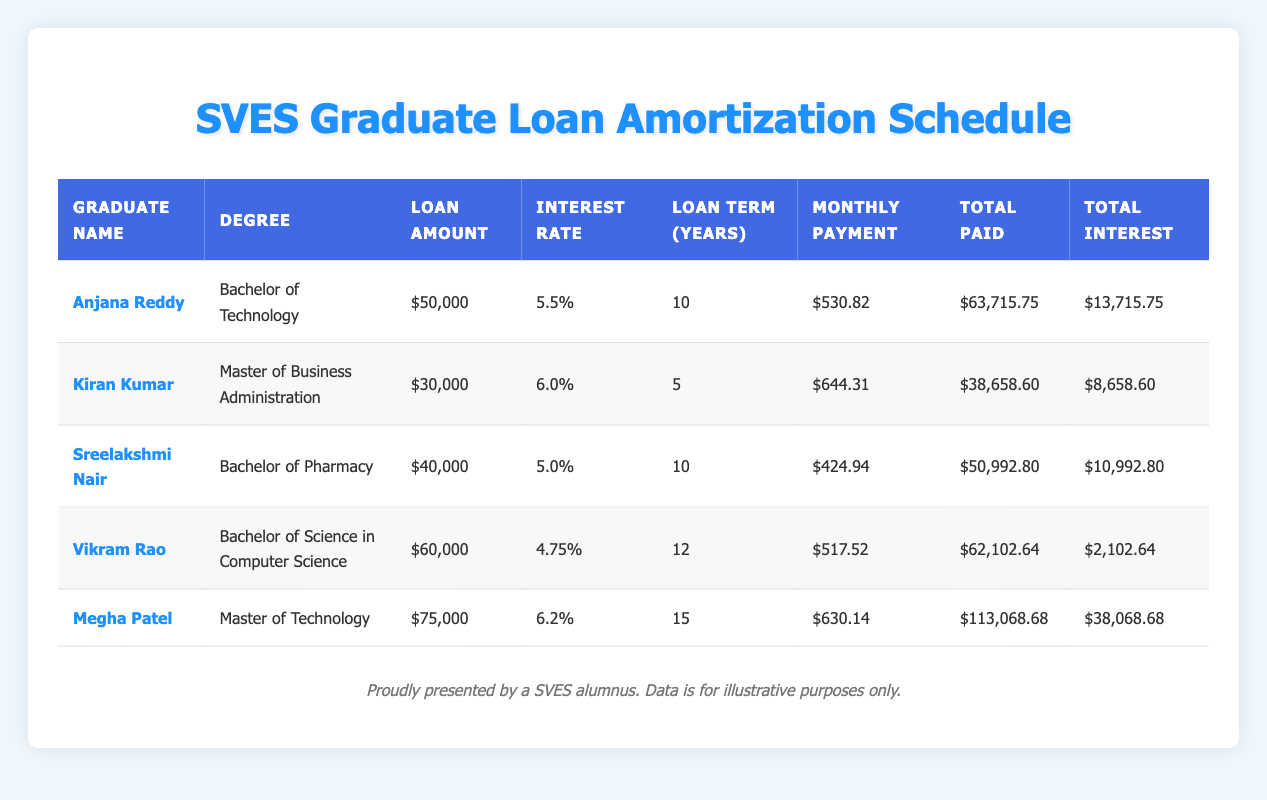What is the loan amount taken by Anjana Reddy? In the table, Anjana Reddy's information displays her loan amount clearly. Under the "Loan Amount" column, it shows $50,000 as her loan.
Answer: $50,000 What is the monthly payment for Kiran Kumar? Kiran Kumar's monthly payment can be found in the "Monthly Payment" column next to his name. It lists $644.31, which is the amount he will pay monthly for his loan.
Answer: $644.31 Which graduate has the highest total interest paid? To find the graduate with the highest total interest paid, we can look at the "Total Interest" column and compare the values. Megha Patel has $38,068.68, which is higher than all other graduates' totals.
Answer: Megha Patel What is the average monthly payment of all graduates? To find the average monthly payment, we take the sum of all monthly payments: $530.82 + $644.31 + $424.94 + $517.52 + $630.14 = $2,447.73. There are 5 graduates, so dividing the total by 5 gives us an average of 2,447.73 / 5 = $489.55.
Answer: $489.55 Does Sreelakshmi Nair have a higher total paid amount than Vikram Rao? Sreelakshmi Nair's total paid amount is $50,992.80, and Vikram Rao's total paid amount is $62,102.64. Since $50,992.80 is not greater than $62,102.64, the answer is no.
Answer: No How much total interest does Megha Patel pay compared to Anjana Reddy? Megha Patel's total interest paid is $38,068.68, and Anjana Reddy's total interest is $13,715.75. The difference is $38,068.68 - $13,715.75 = $24,352.93, indicating she pays more interest by this amount.
Answer: $24,352.93 What is the degree of the graduate with the least total paid amount? From the table, we compare total amounts paid: Anjana Reddy paid $63,715.75, Kiran Kumar paid $38,658.60, Sreelakshmi Nair paid $50,992.80, Vikram Rao paid $62,102.64, and Megha Patel paid $113,068.68. Kiran Kumar has the lowest at $38,658.60. Looking at his row shows that his degree is Master of Business Administration.
Answer: Master of Business Administration Are all graduates' interest rates above 4%? By checking the interest rates, we find Anjana Reddy has 5.5%, Kiran Kumar has 6.0%, Sreelakshmi Nair has 5.0%, Vikram Rao has 4.75%, and Megha Patel has 6.2%. Since Vikram Rao's rate is 4.75%, which is slightly above 4%, it indicates all rates are above 4%.
Answer: Yes 